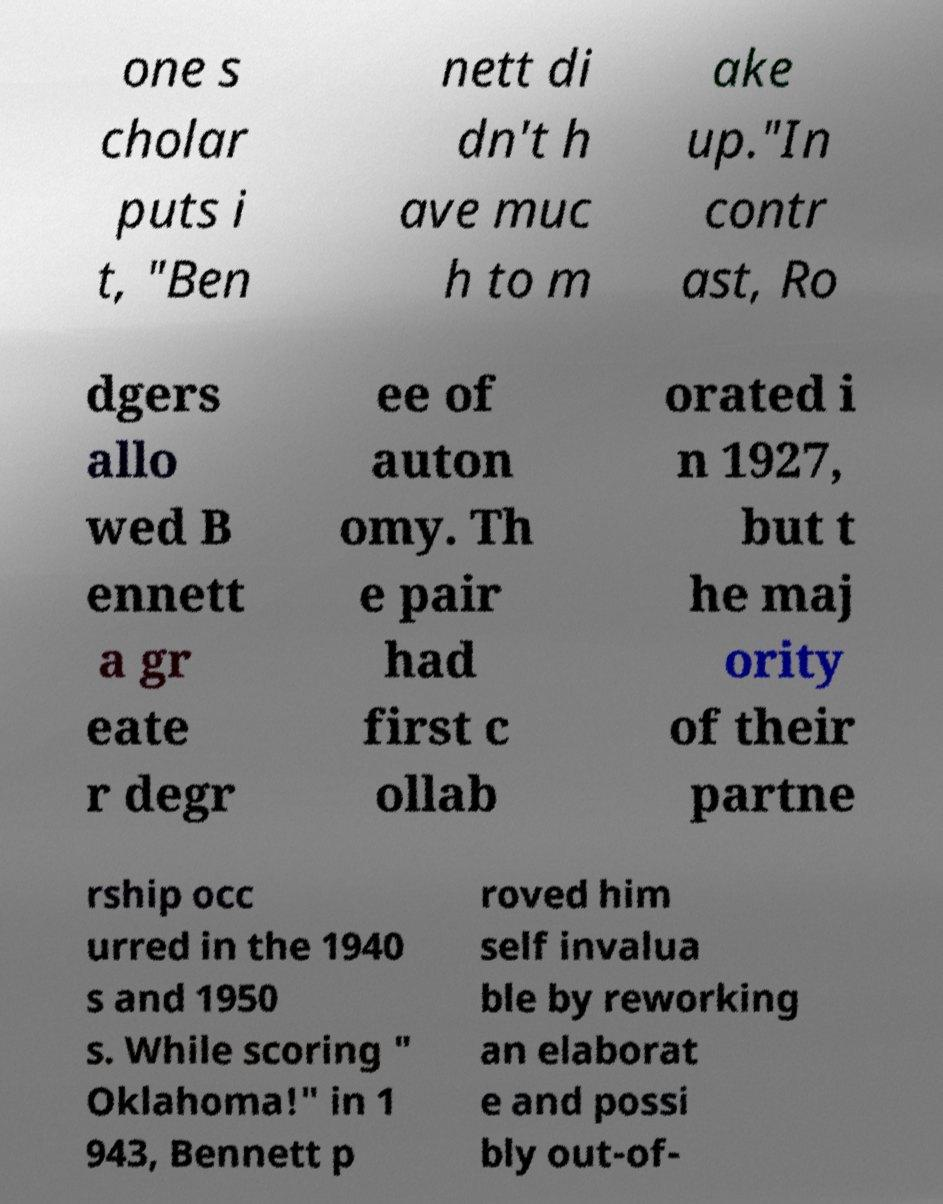What messages or text are displayed in this image? I need them in a readable, typed format. one s cholar puts i t, "Ben nett di dn't h ave muc h to m ake up."In contr ast, Ro dgers allo wed B ennett a gr eate r degr ee of auton omy. Th e pair had first c ollab orated i n 1927, but t he maj ority of their partne rship occ urred in the 1940 s and 1950 s. While scoring " Oklahoma!" in 1 943, Bennett p roved him self invalua ble by reworking an elaborat e and possi bly out-of- 